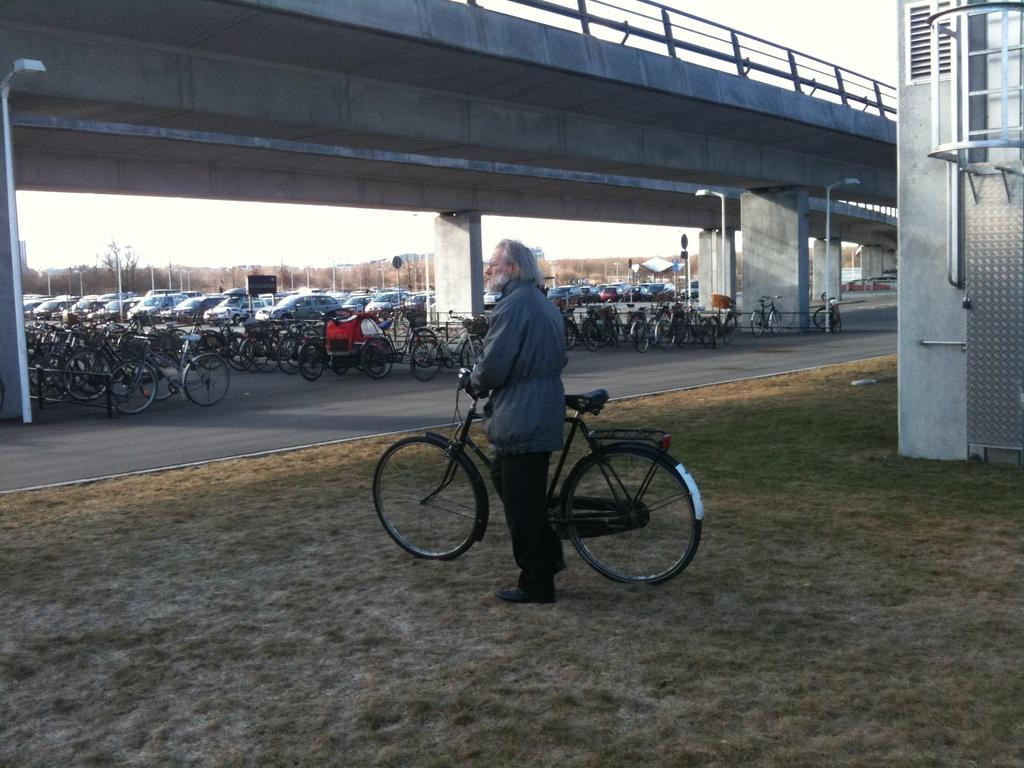What is the main subject in the center of the image? There is a man standing in the center of the image. What is the man holding in the image? The man is holding a bicycle. What can be seen on the right side of the image? There is a tanker on the right side of the image. Can you describe the background of the image? In the background, there are poles, bicycles, cars, a bridge, and the sky. What type of turkey can be seen in the image? There is no turkey present in the image. Can you tell me the name of the man's daughter in the image? There is no mention of a daughter in the image. 